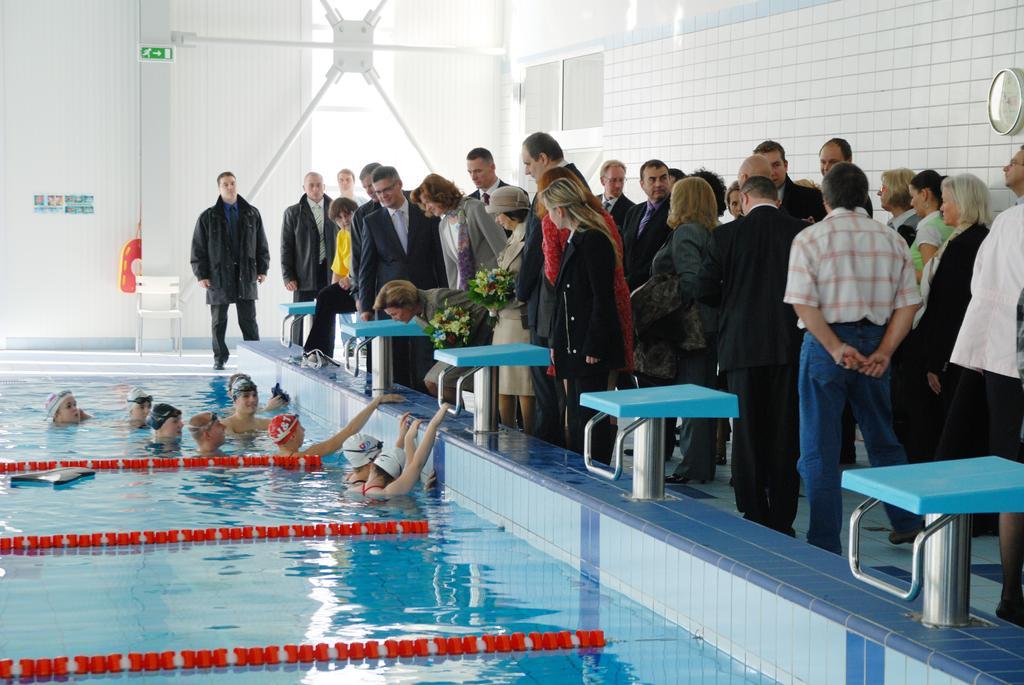How would you summarize this image in a sentence or two? In this picture I can see there is a swimming pool into left and there are few people in the pool. There are few people standing at the right side, among them few are wearing blazers, the men are wearing shirts and pants. The women are wearing dresses and there is a wall on to right with a clock and there is a window in the backdrop. 